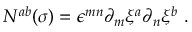Convert formula to latex. <formula><loc_0><loc_0><loc_500><loc_500>N ^ { a b } ( \sigma ) = \epsilon ^ { m n } \partial _ { m } \xi ^ { a } \partial _ { n } \xi ^ { b } \ .</formula> 